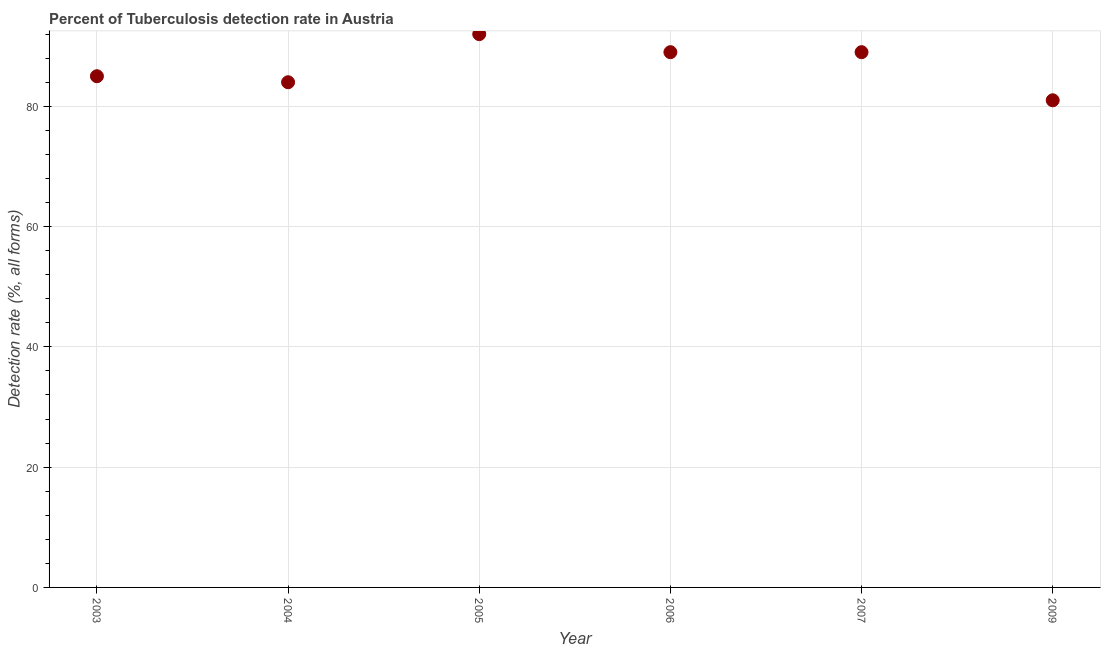What is the detection rate of tuberculosis in 2007?
Make the answer very short. 89. Across all years, what is the maximum detection rate of tuberculosis?
Your answer should be very brief. 92. Across all years, what is the minimum detection rate of tuberculosis?
Your answer should be very brief. 81. What is the sum of the detection rate of tuberculosis?
Give a very brief answer. 520. What is the difference between the detection rate of tuberculosis in 2003 and 2006?
Your response must be concise. -4. What is the average detection rate of tuberculosis per year?
Your response must be concise. 86.67. What is the median detection rate of tuberculosis?
Your answer should be compact. 87. What is the ratio of the detection rate of tuberculosis in 2006 to that in 2009?
Your answer should be very brief. 1.1. Is the difference between the detection rate of tuberculosis in 2005 and 2009 greater than the difference between any two years?
Your answer should be compact. Yes. What is the difference between the highest and the second highest detection rate of tuberculosis?
Give a very brief answer. 3. What is the difference between the highest and the lowest detection rate of tuberculosis?
Offer a very short reply. 11. In how many years, is the detection rate of tuberculosis greater than the average detection rate of tuberculosis taken over all years?
Offer a very short reply. 3. Does the detection rate of tuberculosis monotonically increase over the years?
Provide a succinct answer. No. What is the difference between two consecutive major ticks on the Y-axis?
Provide a short and direct response. 20. Are the values on the major ticks of Y-axis written in scientific E-notation?
Offer a very short reply. No. Does the graph contain any zero values?
Offer a terse response. No. What is the title of the graph?
Offer a very short reply. Percent of Tuberculosis detection rate in Austria. What is the label or title of the Y-axis?
Keep it short and to the point. Detection rate (%, all forms). What is the Detection rate (%, all forms) in 2003?
Provide a short and direct response. 85. What is the Detection rate (%, all forms) in 2004?
Offer a terse response. 84. What is the Detection rate (%, all forms) in 2005?
Make the answer very short. 92. What is the Detection rate (%, all forms) in 2006?
Keep it short and to the point. 89. What is the Detection rate (%, all forms) in 2007?
Make the answer very short. 89. What is the Detection rate (%, all forms) in 2009?
Give a very brief answer. 81. What is the difference between the Detection rate (%, all forms) in 2003 and 2007?
Make the answer very short. -4. What is the difference between the Detection rate (%, all forms) in 2003 and 2009?
Provide a short and direct response. 4. What is the difference between the Detection rate (%, all forms) in 2004 and 2005?
Give a very brief answer. -8. What is the difference between the Detection rate (%, all forms) in 2004 and 2006?
Provide a succinct answer. -5. What is the difference between the Detection rate (%, all forms) in 2004 and 2007?
Your answer should be compact. -5. What is the difference between the Detection rate (%, all forms) in 2004 and 2009?
Offer a terse response. 3. What is the difference between the Detection rate (%, all forms) in 2005 and 2006?
Your answer should be very brief. 3. What is the difference between the Detection rate (%, all forms) in 2005 and 2007?
Ensure brevity in your answer.  3. What is the difference between the Detection rate (%, all forms) in 2006 and 2007?
Your response must be concise. 0. What is the difference between the Detection rate (%, all forms) in 2006 and 2009?
Your response must be concise. 8. What is the difference between the Detection rate (%, all forms) in 2007 and 2009?
Give a very brief answer. 8. What is the ratio of the Detection rate (%, all forms) in 2003 to that in 2005?
Your answer should be compact. 0.92. What is the ratio of the Detection rate (%, all forms) in 2003 to that in 2006?
Provide a short and direct response. 0.95. What is the ratio of the Detection rate (%, all forms) in 2003 to that in 2007?
Offer a terse response. 0.95. What is the ratio of the Detection rate (%, all forms) in 2003 to that in 2009?
Provide a succinct answer. 1.05. What is the ratio of the Detection rate (%, all forms) in 2004 to that in 2006?
Offer a very short reply. 0.94. What is the ratio of the Detection rate (%, all forms) in 2004 to that in 2007?
Give a very brief answer. 0.94. What is the ratio of the Detection rate (%, all forms) in 2004 to that in 2009?
Make the answer very short. 1.04. What is the ratio of the Detection rate (%, all forms) in 2005 to that in 2006?
Your answer should be compact. 1.03. What is the ratio of the Detection rate (%, all forms) in 2005 to that in 2007?
Provide a succinct answer. 1.03. What is the ratio of the Detection rate (%, all forms) in 2005 to that in 2009?
Ensure brevity in your answer.  1.14. What is the ratio of the Detection rate (%, all forms) in 2006 to that in 2007?
Offer a very short reply. 1. What is the ratio of the Detection rate (%, all forms) in 2006 to that in 2009?
Make the answer very short. 1.1. What is the ratio of the Detection rate (%, all forms) in 2007 to that in 2009?
Keep it short and to the point. 1.1. 